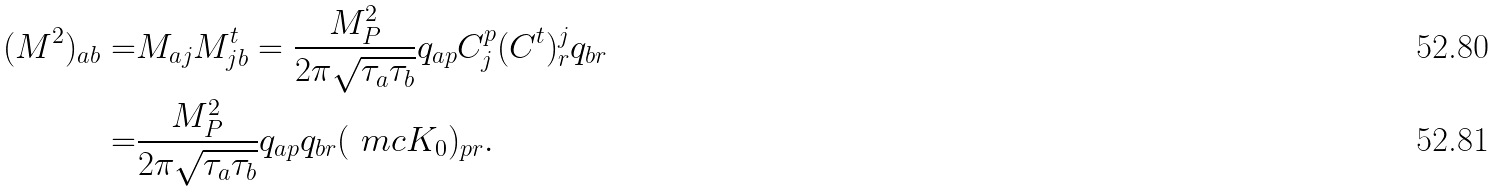Convert formula to latex. <formula><loc_0><loc_0><loc_500><loc_500>( M ^ { 2 } ) _ { a b } = & M _ { a j } M ^ { t } _ { j b } = \frac { M _ { P } ^ { 2 } } { 2 \pi \sqrt { \tau _ { a } \tau _ { b } } } q _ { a p } C ^ { p } _ { j } ( C ^ { t } ) ^ { j } _ { r } q _ { b r } \\ = & \frac { M _ { P } ^ { 2 } } { 2 \pi \sqrt { \tau _ { a } \tau _ { b } } } q _ { a p } q _ { b r } ( \ m c { K } _ { 0 } ) _ { p r } .</formula> 